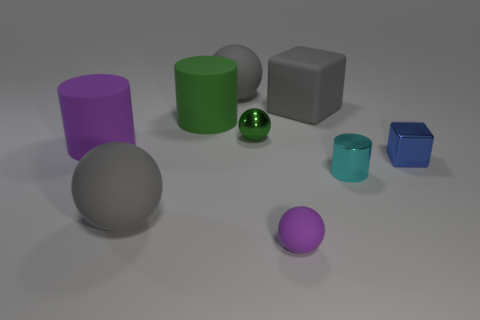Can you explain the materials the objects are made of? Certainly! In the image, there appears to be a variety of textured surfaces suggesting different materials. The objects resemble a composition of matte and shiny finishes. For instance, the large gray sphere and cubes look like they have matte surfaces that could be made of plastic or rubber, while the small green sphere has a reflective, glossy finish indicative of glass or polished metal. 